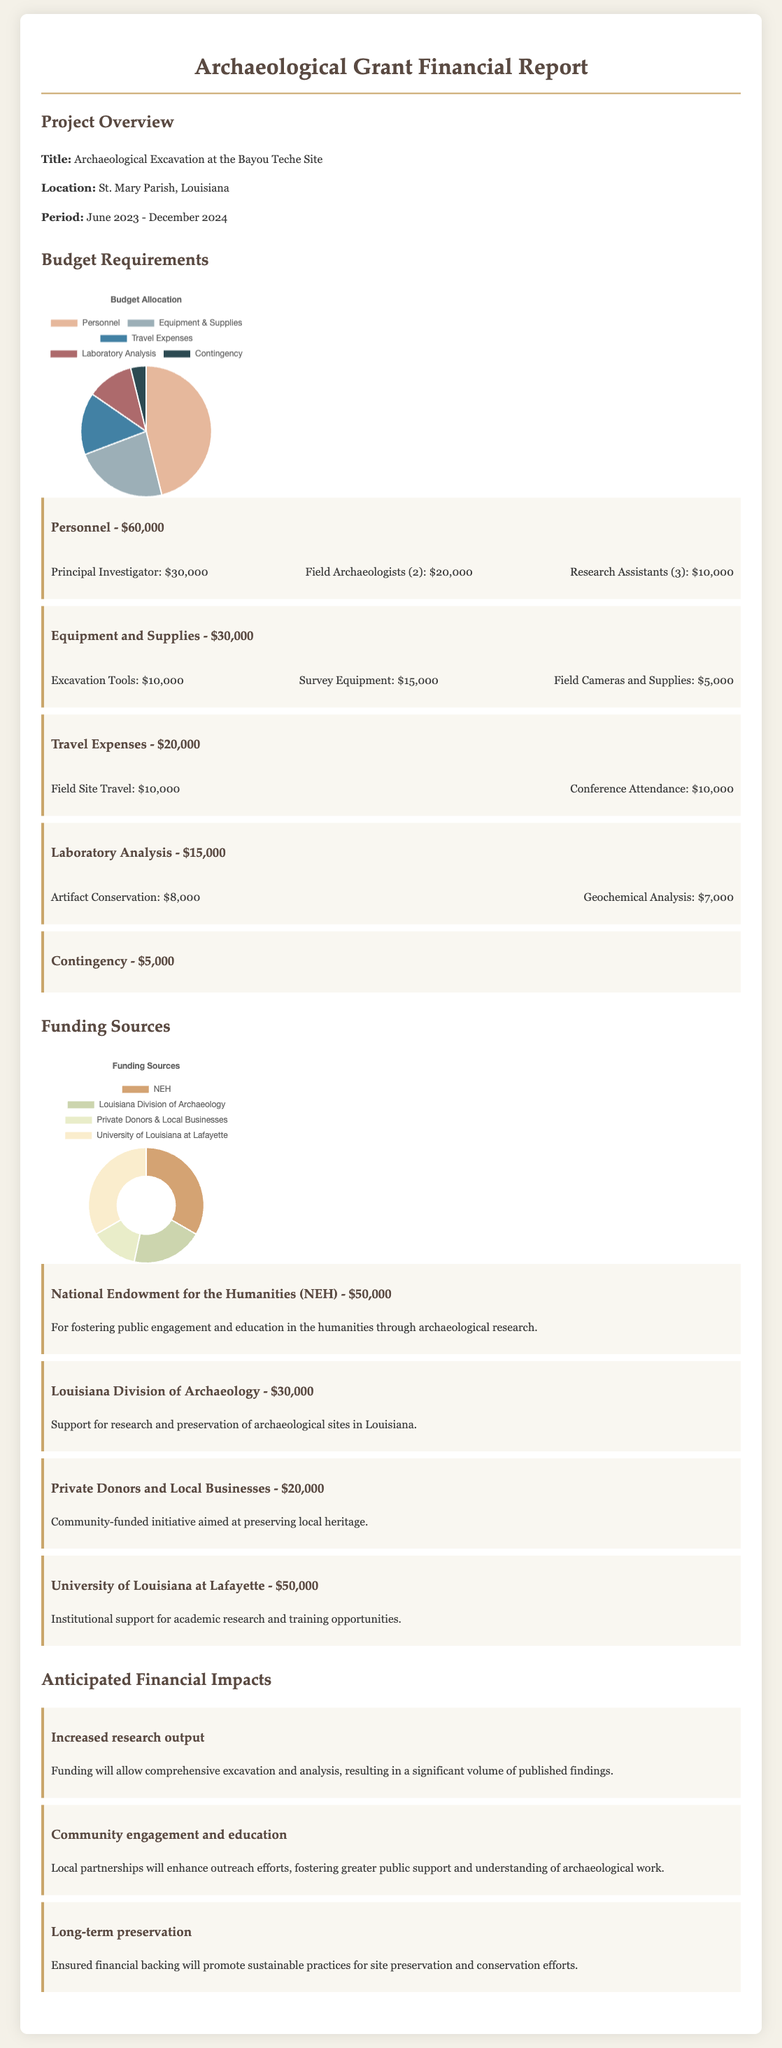What is the title of the project? The title of the project is stated in the document's Project Overview section.
Answer: Archaeological Excavation at the Bayou Teche Site What is the total budget allocated for Personnel? The Personnel section of the Budget Requirements provides the allocation for this category.
Answer: $60,000 How much funding is provided by the National Endowment for the Humanities? The Funding Sources section details the specific amount from each source, including NEH.
Answer: $50,000 What is the period of the project? The period is mentioned in the Project Overview section of the document.
Answer: June 2023 - December 2024 What is the funding amount from Private Donors and Local Businesses? This is listed in the Funding Sources section along with details for each contributor.
Answer: $20,000 What is one anticipated financial impact of the project? The document mentions various anticipated financial impacts in their respective section.
Answer: Increased research output How many field archaeologists are included in the budget for Personnel? This detail can be found in the breakdown of costs within the Personnel budget item.
Answer: 2 What is the amount allocated for Travel Expenses? The Travel Expenses item in the Budget Requirements specifies the total for this category.
Answer: $20,000 Which institution provides $50,000 in funding? This information is included in the Funding Sources section, identifying the contributing institutions.
Answer: University of Louisiana at Lafayette 